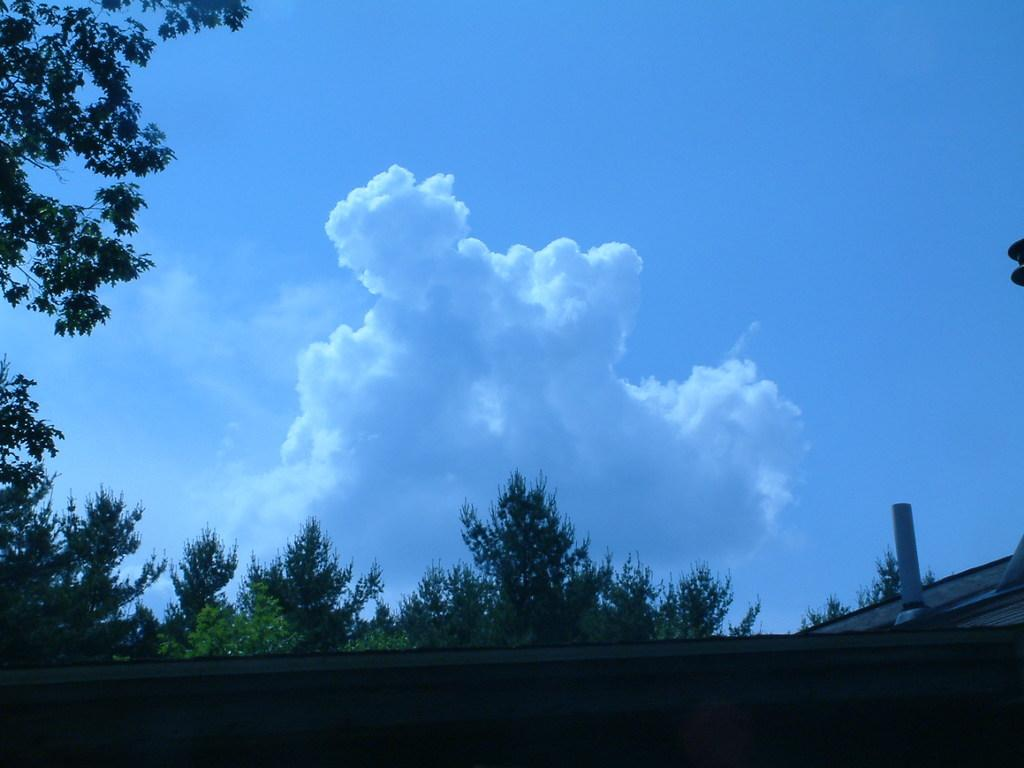What type of natural elements can be seen in the image? There are clouds and trees visible in the image. What type of man-made structure can be seen in the image? There is a roof visible in the image. What is visible in the background of the image? The sky is visible in the image. How many chairs are visible in the image? There are no chairs present in the image. What type of hand can be seen interacting with the clouds in the image? There are no hands visible in the image, and the clouds are not being interacted with. 